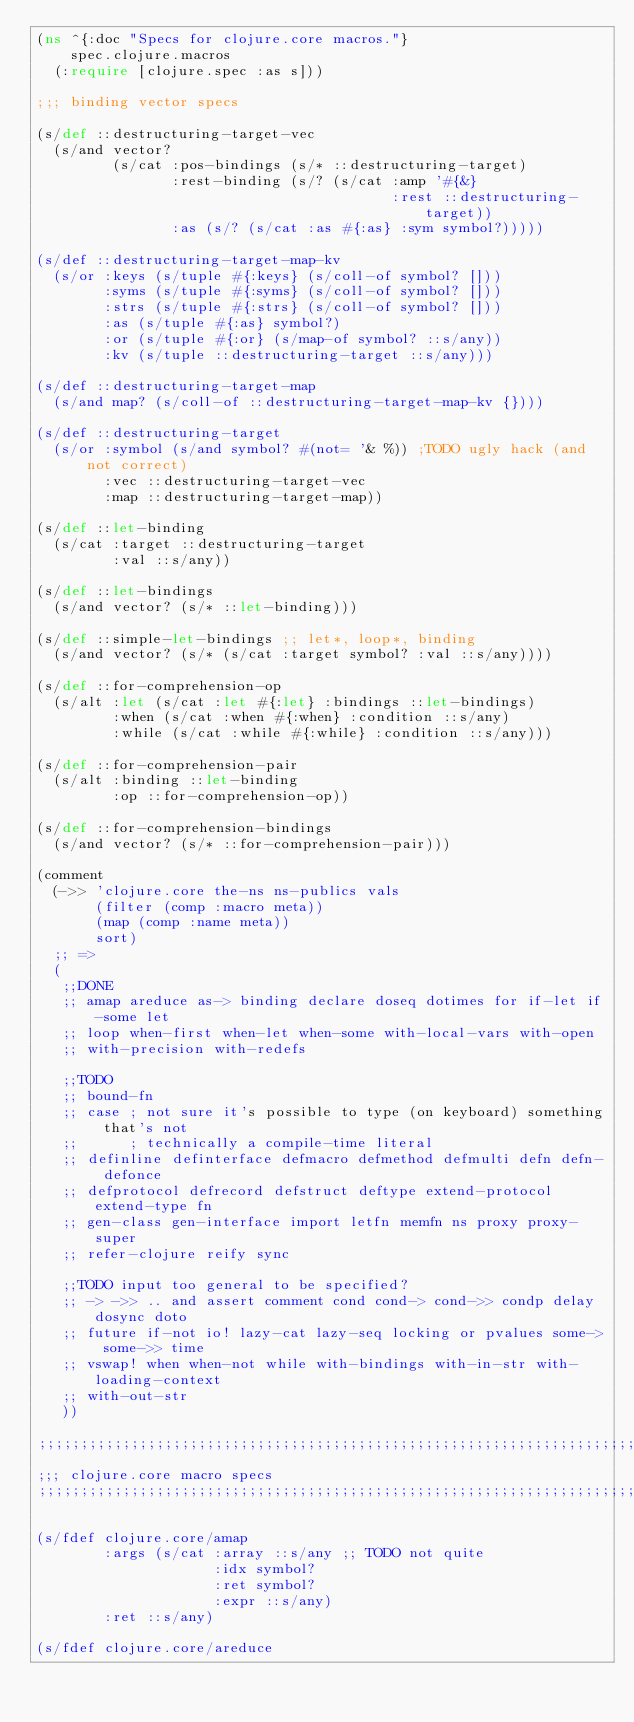Convert code to text. <code><loc_0><loc_0><loc_500><loc_500><_Clojure_>(ns ^{:doc "Specs for clojure.core macros."}
    spec.clojure.macros
  (:require [clojure.spec :as s]))

;;; binding vector specs

(s/def ::destructuring-target-vec
  (s/and vector?
         (s/cat :pos-bindings (s/* ::destructuring-target)
                :rest-binding (s/? (s/cat :amp '#{&}
                                          :rest ::destructuring-target))
                :as (s/? (s/cat :as #{:as} :sym symbol?)))))

(s/def ::destructuring-target-map-kv
  (s/or :keys (s/tuple #{:keys} (s/coll-of symbol? []))
        :syms (s/tuple #{:syms} (s/coll-of symbol? []))
        :strs (s/tuple #{:strs} (s/coll-of symbol? []))
        :as (s/tuple #{:as} symbol?)
        :or (s/tuple #{:or} (s/map-of symbol? ::s/any))
        :kv (s/tuple ::destructuring-target ::s/any)))

(s/def ::destructuring-target-map
  (s/and map? (s/coll-of ::destructuring-target-map-kv {})))

(s/def ::destructuring-target
  (s/or :symbol (s/and symbol? #(not= '& %)) ;TODO ugly hack (and not correct)
        :vec ::destructuring-target-vec
        :map ::destructuring-target-map))

(s/def ::let-binding
  (s/cat :target ::destructuring-target
         :val ::s/any))

(s/def ::let-bindings
  (s/and vector? (s/* ::let-binding)))

(s/def ::simple-let-bindings ;; let*, loop*, binding
  (s/and vector? (s/* (s/cat :target symbol? :val ::s/any))))

(s/def ::for-comprehension-op
  (s/alt :let (s/cat :let #{:let} :bindings ::let-bindings)
         :when (s/cat :when #{:when} :condition ::s/any)
         :while (s/cat :while #{:while} :condition ::s/any)))

(s/def ::for-comprehension-pair
  (s/alt :binding ::let-binding
         :op ::for-comprehension-op))

(s/def ::for-comprehension-bindings
  (s/and vector? (s/* ::for-comprehension-pair)))

(comment
  (->> 'clojure.core the-ns ns-publics vals
       (filter (comp :macro meta))
       (map (comp :name meta))
       sort)
  ;; =>
  (
   ;;DONE
   ;; amap areduce as-> binding declare doseq dotimes for if-let if-some let
   ;; loop when-first when-let when-some with-local-vars with-open
   ;; with-precision with-redefs

   ;;TODO
   ;; bound-fn
   ;; case ; not sure it's possible to type (on keyboard) something that's not
   ;;      ; technically a compile-time literal
   ;; definline definterface defmacro defmethod defmulti defn defn- defonce
   ;; defprotocol defrecord defstruct deftype extend-protocol extend-type fn
   ;; gen-class gen-interface import letfn memfn ns proxy proxy-super
   ;; refer-clojure reify sync

   ;;TODO input too general to be specified?
   ;; -> ->> .. and assert comment cond cond-> cond->> condp delay dosync doto
   ;; future if-not io! lazy-cat lazy-seq locking or pvalues some-> some->> time
   ;; vswap! when when-not while with-bindings with-in-str with-loading-context
   ;; with-out-str
   ))

;;;;;;;;;;;;;;;;;;;;;;;;;;;;;;;;;;;;;;;;;;;;;;;;;;;;;;;;;;;;;;;;;;;;;;;;;;;;;;
;;; clojure.core macro specs
;;;;;;;;;;;;;;;;;;;;;;;;;;;;;;;;;;;;;;;;;;;;;;;;;;;;;;;;;;;;;;;;;;;;;;;;;;;;;;

(s/fdef clojure.core/amap
        :args (s/cat :array ::s/any ;; TODO not quite
                     :idx symbol?
                     :ret symbol?
                     :expr ::s/any)
        :ret ::s/any)

(s/fdef clojure.core/areduce</code> 